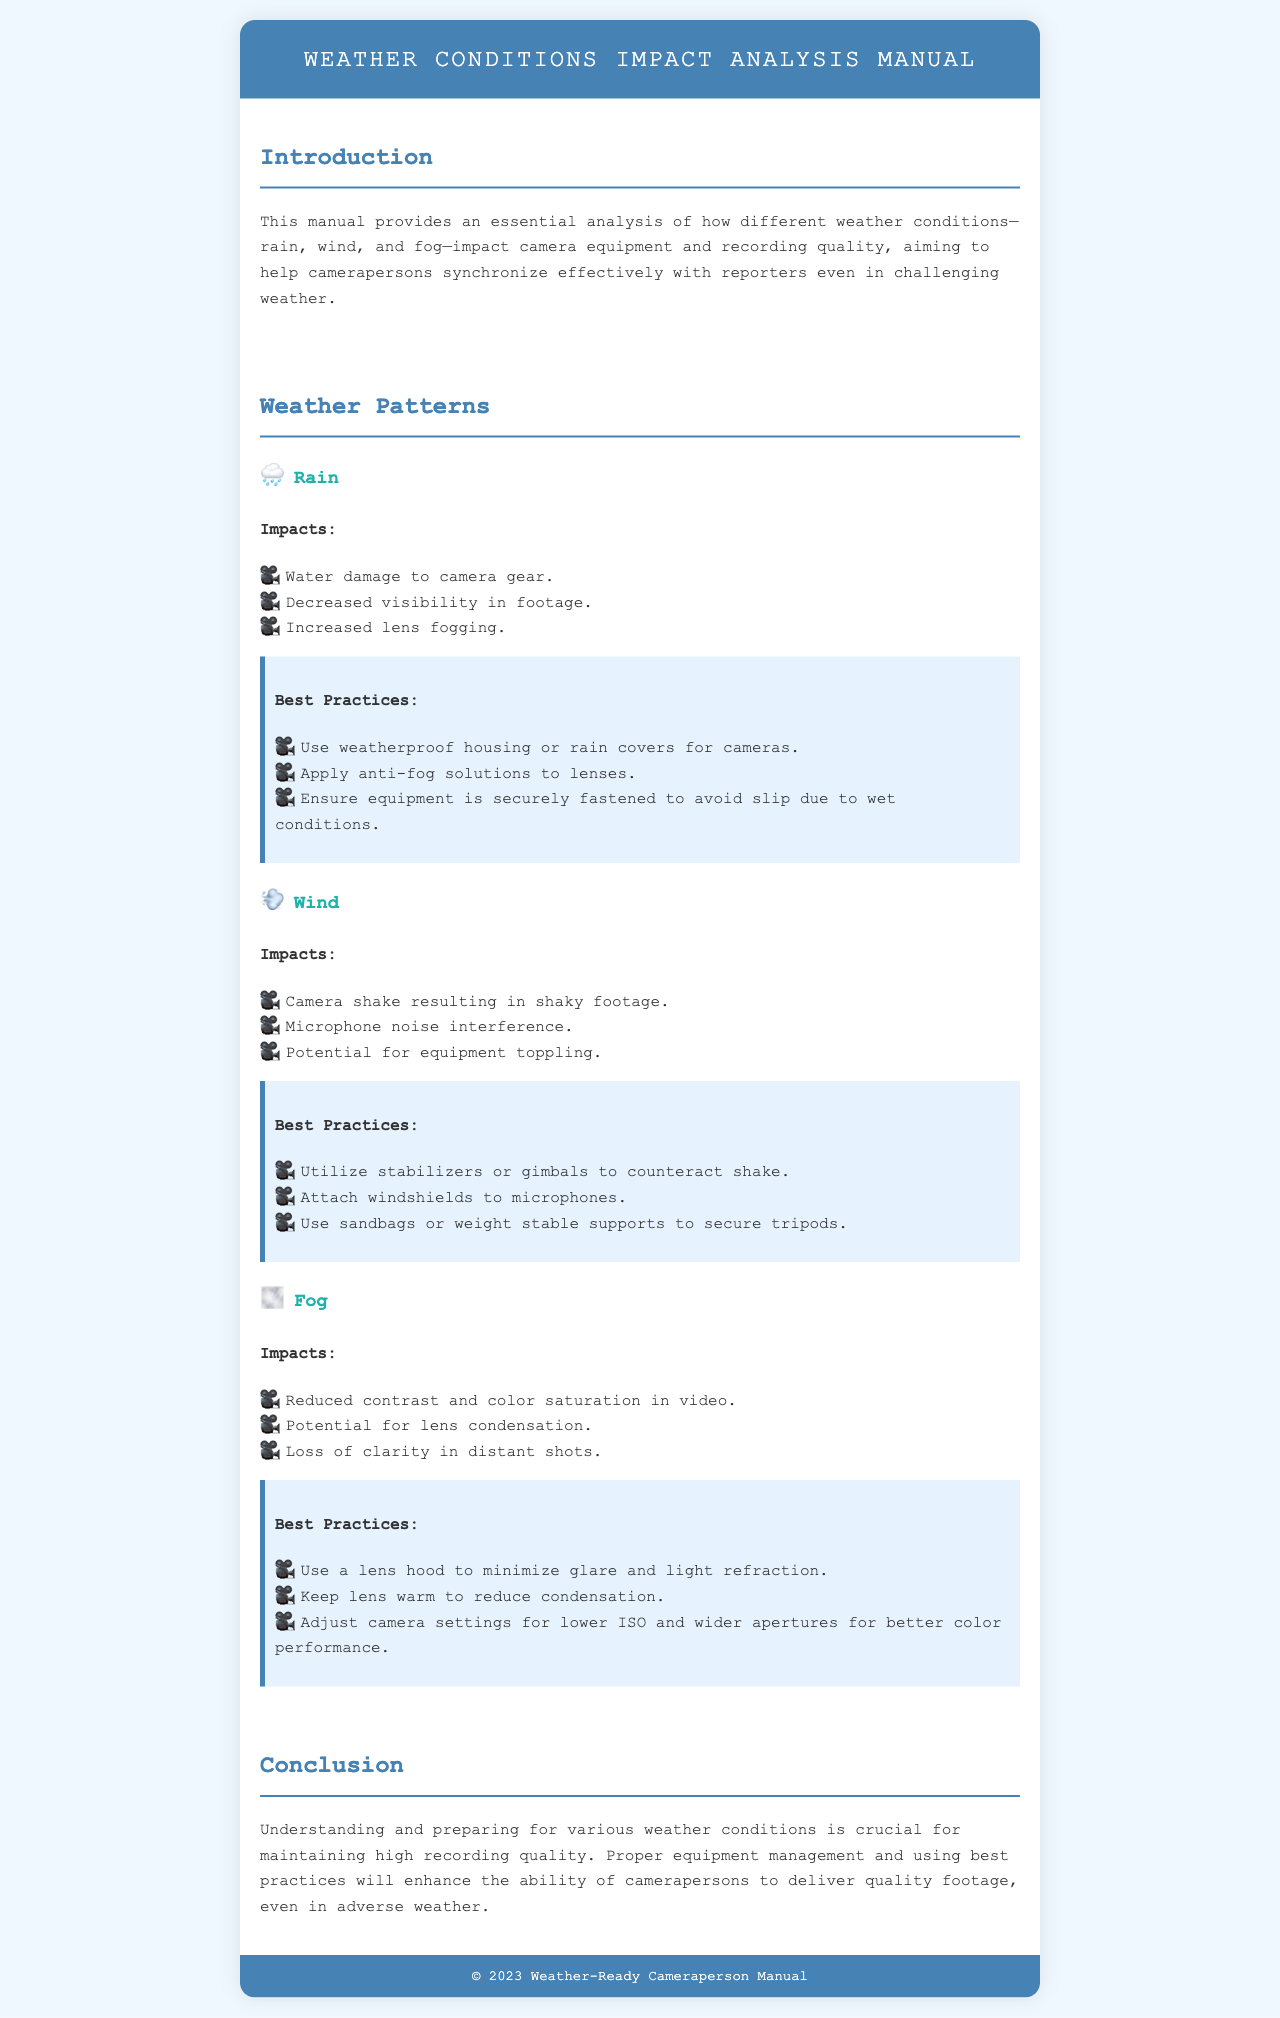What do rain conditions decrease in footage? The document states that rain leads to decreased visibility in footage.
Answer: Decreased visibility What are the potentials of wind on equipment? The document lists the potential for equipment toppling as an impact of wind.
Answer: Potential for equipment toppling What tool can be used to counteract camera shake in windy conditions? The manual suggests utilizing stabilizers or gimbals to counteract shake.
Answer: Stabilizers or gimbals What should be applied to lenses in rainy conditions? The best practice for rain is to apply anti-fog solutions to lenses.
Answer: Anti-fog solutions What happens to video color saturation in fog? The document indicates that fog leads to reduced contrast and color saturation in video.
Answer: Reduced contrast and color saturation What should be used to minimize glare in fog? The manual recommends using a lens hood to minimize glare and light refraction in fog.
Answer: Lens hood What type of housing should be used for camera protection in rain? The document advises the use of weatherproof housing or rain covers for cameras.
Answer: Weatherproof housing or rain covers How does the manual describe the importance of preparing for weather conditions? The conclusion emphasizes that understanding and preparing for weather conditions is crucial for maintaining high recording quality.
Answer: Crucial for maintaining high recording quality 